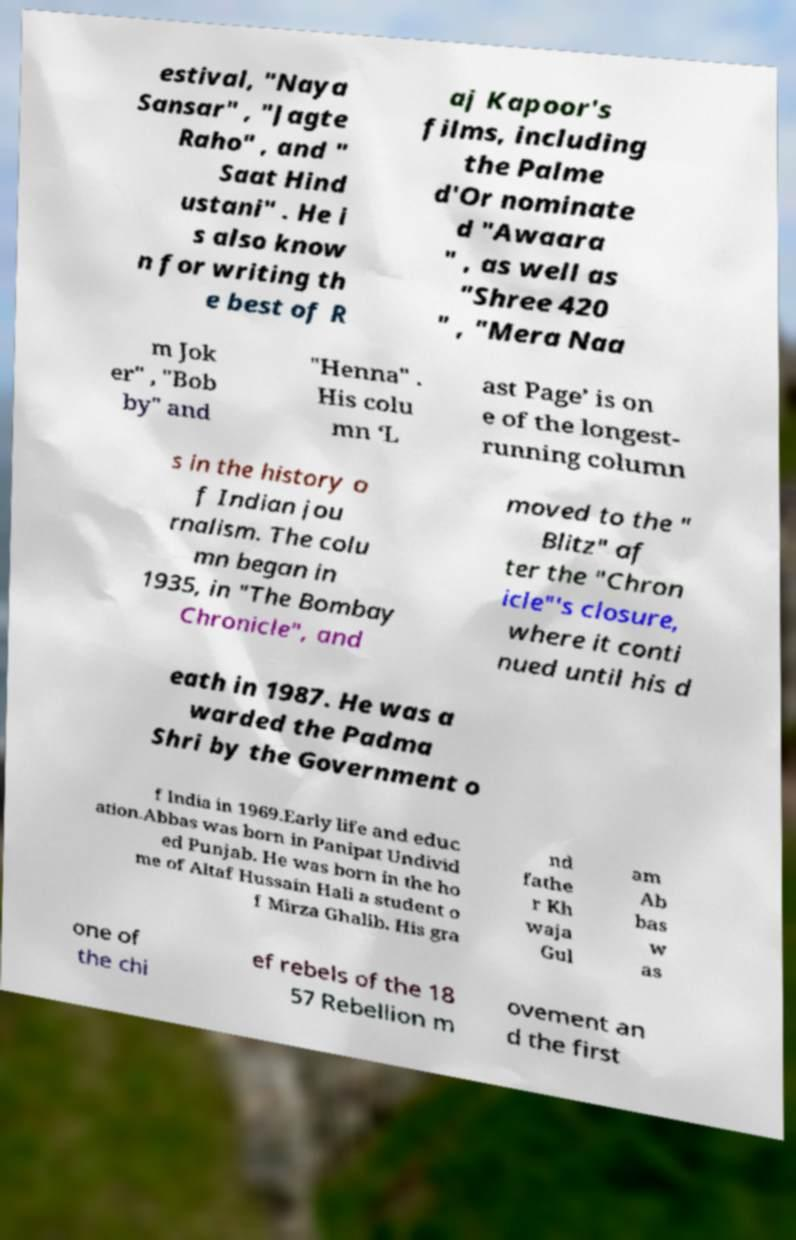Please read and relay the text visible in this image. What does it say? estival, "Naya Sansar" , "Jagte Raho" , and " Saat Hind ustani" . He i s also know n for writing th e best of R aj Kapoor's films, including the Palme d'Or nominate d "Awaara " , as well as "Shree 420 " , "Mera Naa m Jok er" , "Bob by" and "Henna" . His colu mn ‘L ast Page’ is on e of the longest- running column s in the history o f Indian jou rnalism. The colu mn began in 1935, in "The Bombay Chronicle", and moved to the " Blitz" af ter the "Chron icle"'s closure, where it conti nued until his d eath in 1987. He was a warded the Padma Shri by the Government o f India in 1969.Early life and educ ation.Abbas was born in Panipat Undivid ed Punjab. He was born in the ho me of Altaf Hussain Hali a student o f Mirza Ghalib. His gra nd fathe r Kh waja Gul am Ab bas w as one of the chi ef rebels of the 18 57 Rebellion m ovement an d the first 